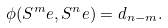<formula> <loc_0><loc_0><loc_500><loc_500>\phi ( { S ^ { m } } e , { S ^ { n } } e ) = d _ { n - m } .</formula> 